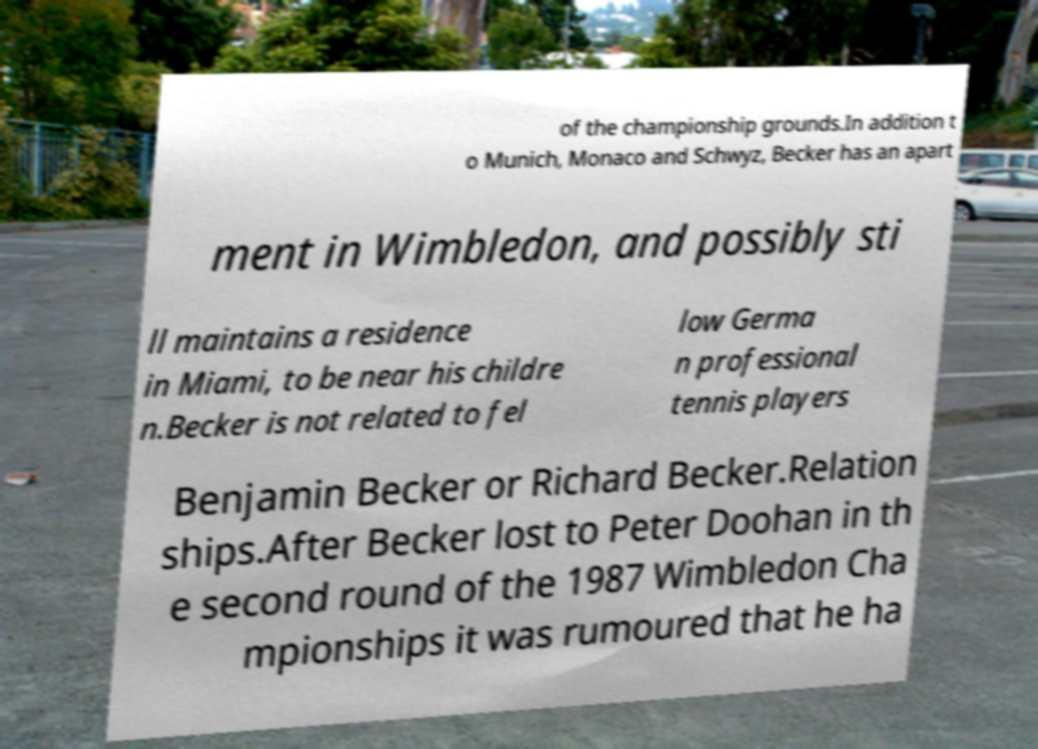For documentation purposes, I need the text within this image transcribed. Could you provide that? of the championship grounds.In addition t o Munich, Monaco and Schwyz, Becker has an apart ment in Wimbledon, and possibly sti ll maintains a residence in Miami, to be near his childre n.Becker is not related to fel low Germa n professional tennis players Benjamin Becker or Richard Becker.Relation ships.After Becker lost to Peter Doohan in th e second round of the 1987 Wimbledon Cha mpionships it was rumoured that he ha 